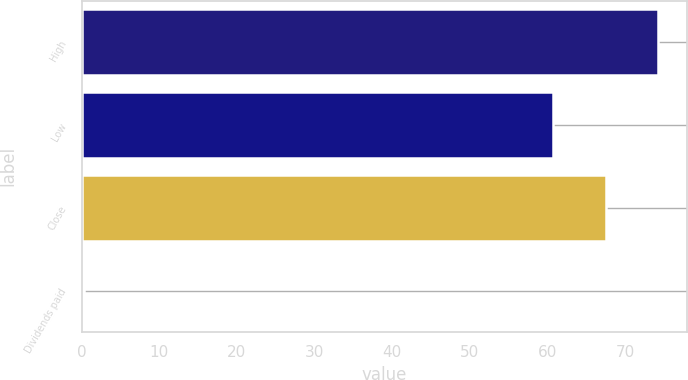<chart> <loc_0><loc_0><loc_500><loc_500><bar_chart><fcel>High<fcel>Low<fcel>Close<fcel>Dividends paid<nl><fcel>74.31<fcel>60.73<fcel>67.52<fcel>0.32<nl></chart> 